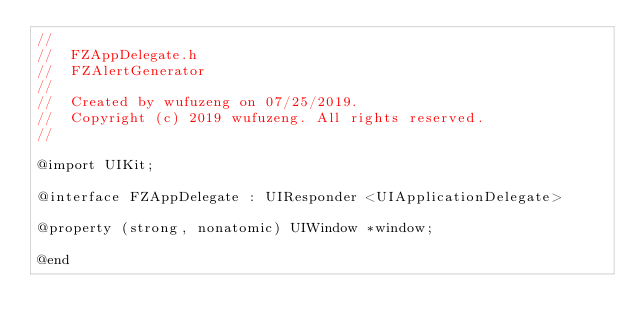Convert code to text. <code><loc_0><loc_0><loc_500><loc_500><_C_>//
//  FZAppDelegate.h
//  FZAlertGenerator
//
//  Created by wufuzeng on 07/25/2019.
//  Copyright (c) 2019 wufuzeng. All rights reserved.
//

@import UIKit;

@interface FZAppDelegate : UIResponder <UIApplicationDelegate>

@property (strong, nonatomic) UIWindow *window;

@end
</code> 